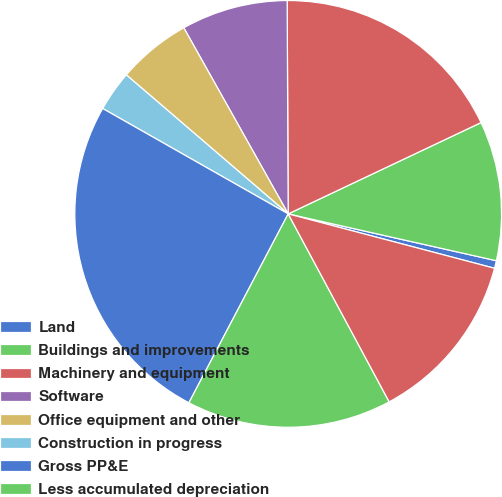Convert chart. <chart><loc_0><loc_0><loc_500><loc_500><pie_chart><fcel>Land<fcel>Buildings and improvements<fcel>Machinery and equipment<fcel>Software<fcel>Office equipment and other<fcel>Construction in progress<fcel>Gross PP&E<fcel>Less accumulated depreciation<fcel>Net PP&E<nl><fcel>0.58%<fcel>10.56%<fcel>18.04%<fcel>8.06%<fcel>5.57%<fcel>3.07%<fcel>25.52%<fcel>15.55%<fcel>13.05%<nl></chart> 